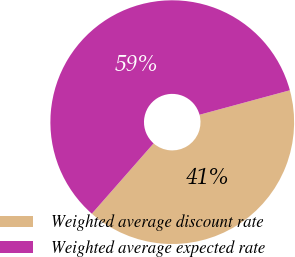<chart> <loc_0><loc_0><loc_500><loc_500><pie_chart><fcel>Weighted average discount rate<fcel>Weighted average expected rate<nl><fcel>40.68%<fcel>59.32%<nl></chart> 